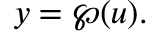Convert formula to latex. <formula><loc_0><loc_0><loc_500><loc_500>y = \wp ( u ) .</formula> 